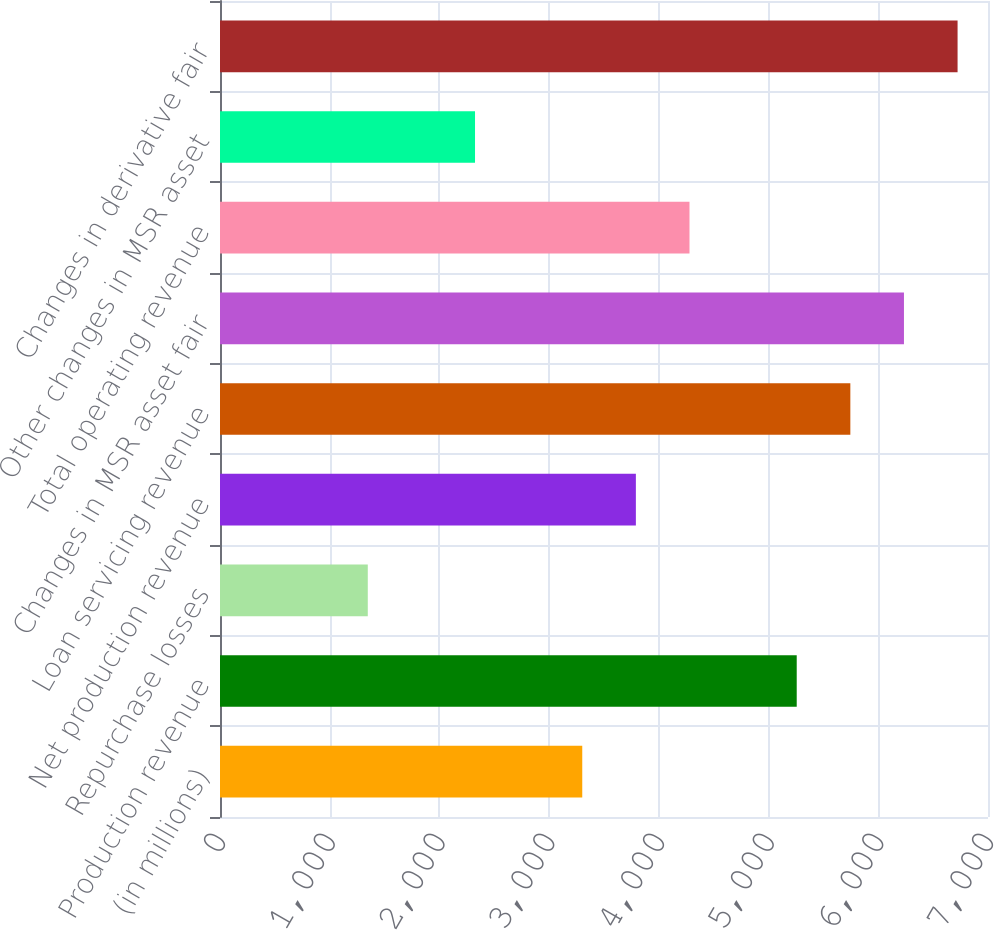Convert chart. <chart><loc_0><loc_0><loc_500><loc_500><bar_chart><fcel>(in millions)<fcel>Production revenue<fcel>Repurchase losses<fcel>Net production revenue<fcel>Loan servicing revenue<fcel>Changes in MSR asset fair<fcel>Total operating revenue<fcel>Other changes in MSR asset<fcel>Changes in derivative fair<nl><fcel>3301.8<fcel>5256.6<fcel>1347<fcel>3790.5<fcel>5745.3<fcel>6234<fcel>4279.2<fcel>2324.4<fcel>6722.7<nl></chart> 